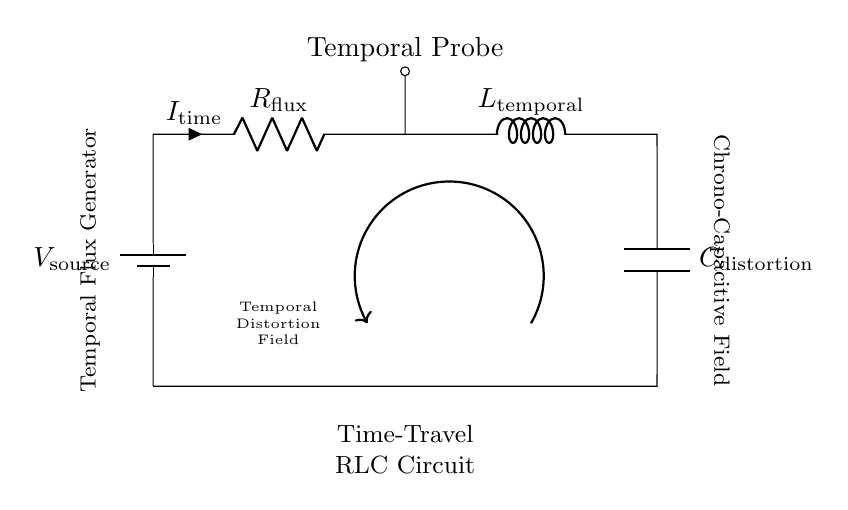What is the current flowing through the circuit? The current flowing through the circuit is denoted as I_time, which represents the flow of electrons in the time-travel device.
Answer: I_time What is the voltage source in the circuit? The voltage source in the circuit is labeled as V_source, providing the necessary electrical energy to drive the components.
Answer: V_source What are the component values of the circuit? The components in the circuit include R_flux for resistance, L_temporal for inductance, and C_distortion for capacitance. Each component is designated to manipulate electrical characteristics for temporal distortion.
Answer: R_flux, L_temporal, C_distortion What is the function of the temporal probe? The temporal probe is used to measure the output or effect of the time-travel circuit at the point where it connects to the circuit. It helps in monitoring the efficiency of temporal distortions created by the circuit's operation.
Answer: Measure temporal distortions How do the components affect time travel capabilities? The resistor, inductor, and capacitor in the circuit work together to create a resonant frequency that can influence time travel. The resistor regulates energy losses, the inductor creates magnetic fields that control charge flow, and the capacitor stores and releases energy to enhance temporal effects, allowing for potential manipulation of time.
Answer: Create resonant frequency What is the role of the chrono-capacitive field? The chrono-capacitive field is a conceptual field created by the actions of the capacitor in the RLC circuit, which aids in stabilizing the temporal distortions generated, potentially allowing for safe time travel.
Answer: Stabilize temporal distortions 